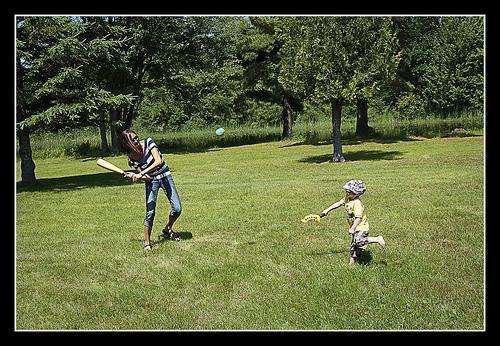How many people are there?
Give a very brief answer. 2. 